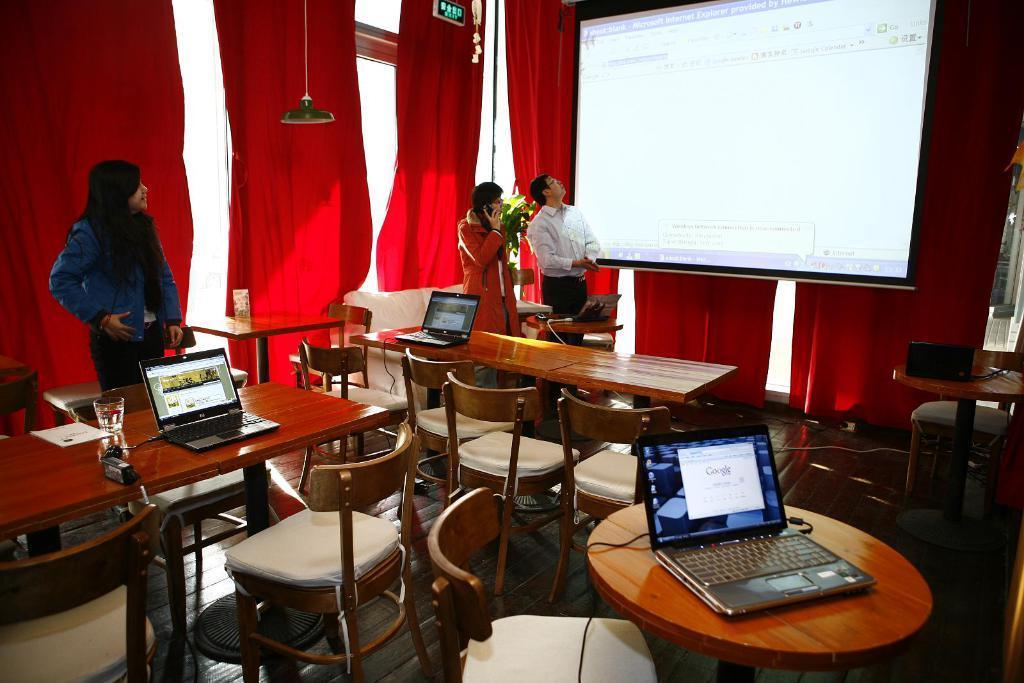Could you give a brief overview of what you see in this image? Two persons are standing and looking to the screen which is display in front of them there is a table on the table we have laptops glass is filled with liquid and some chairs in the left side one woman Standing and looking to the screen back side we have red color cloth. 